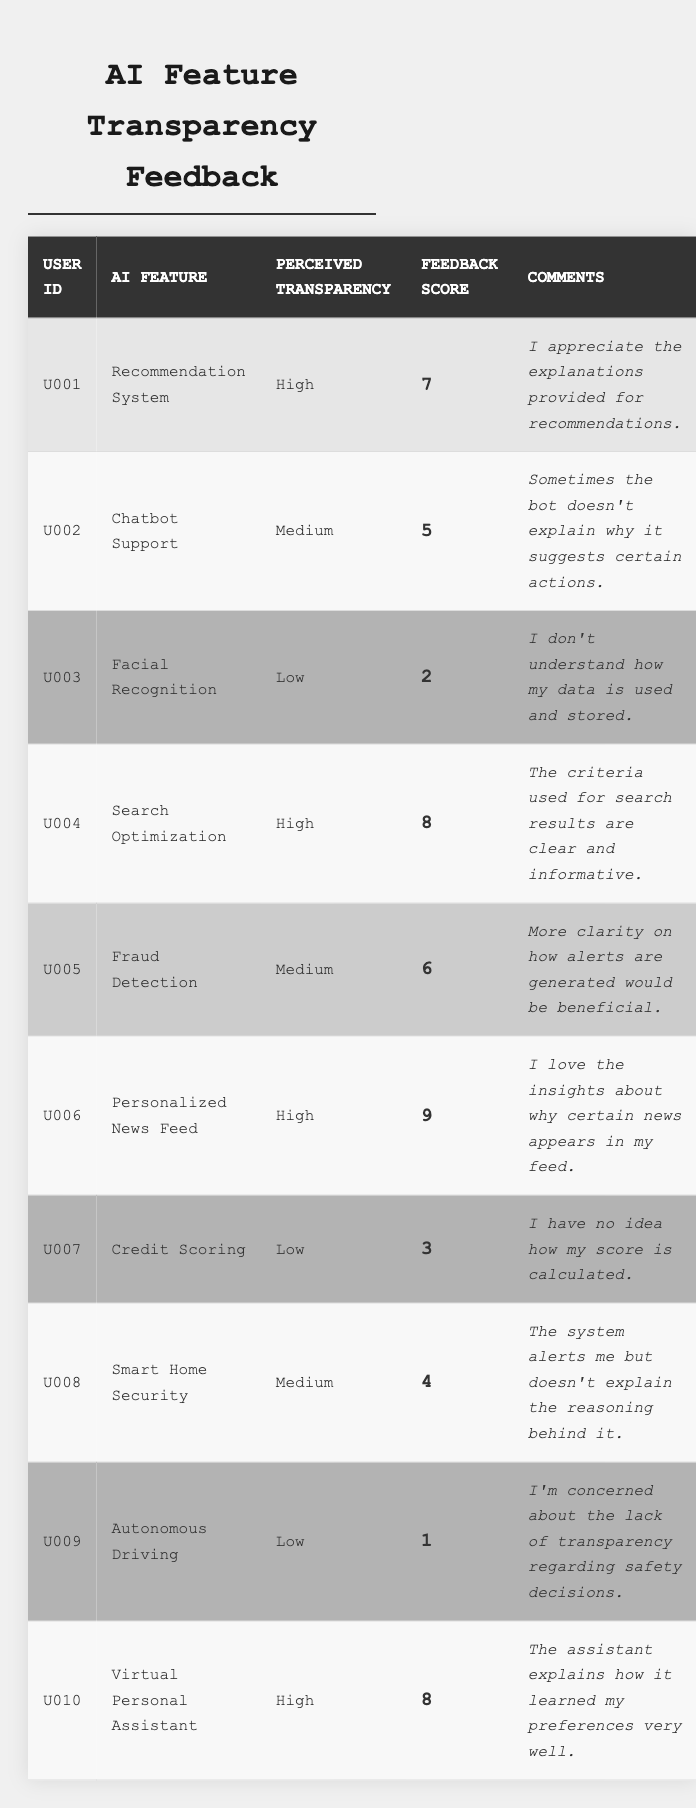What is the highest feedback score recorded in the table? The highest feedback score is seen in the row for the "Personalized News Feed" with a score of 9.
Answer: 9 What AI feature has the lowest perceived transparency? The "Autonomous Driving" feature has the lowest perceived transparency, classified as "Low".
Answer: Autonomous Driving How many AI features received a high perceived transparency rating? There are 4 AI features ("Recommendation System", "Search Optimization", "Personalized News Feed", and "Virtual Personal Assistant") that received a "High" transparency rating.
Answer: 4 What is the average feedback score for AI features with medium perceived transparency? The feedback scores for medium transparency features are 5 (Chatbot Support), 6 (Fraud Detection), and 4 (Smart Home Security). Summing these gives 5 + 6 + 4 = 15. There are 3 data points, so the average is 15 / 3 = 5.
Answer: 5 Which user provided the comment about not understanding how their data is used and stored? User U003 provided the comment expressing confusion about data usage related to "Facial Recognition".
Answer: U003 Are there any AI features rated with a feedback score of 1? Yes, the "Autonomous Driving" feature received a feedback score of 1.
Answer: Yes What is the perceived transparency of the "Credit Scoring" AI feature? The "Credit Scoring" AI feature is rated with a perceived transparency of "Low".
Answer: Low How many users expressed high perceived transparency in their comments? The users U001, U004, U006, and U010 expressed high perceived transparency, totaling 4 users.
Answer: 4 What is the sum of the feedback scores for all AI features rated as low perceived transparency? The feedback scores for low perceived transparency are 2 (Facial Recognition), 3 (Credit Scoring), and 1 (Autonomous Driving). Summing these gives 2 + 3 + 1 = 6.
Answer: 6 Which AI feature has feedback score 6, and what is its perceived transparency? The "Fraud Detection" feature has a feedback score of 6, and its perceived transparency is rated as "Medium".
Answer: Fraud Detection, Medium 